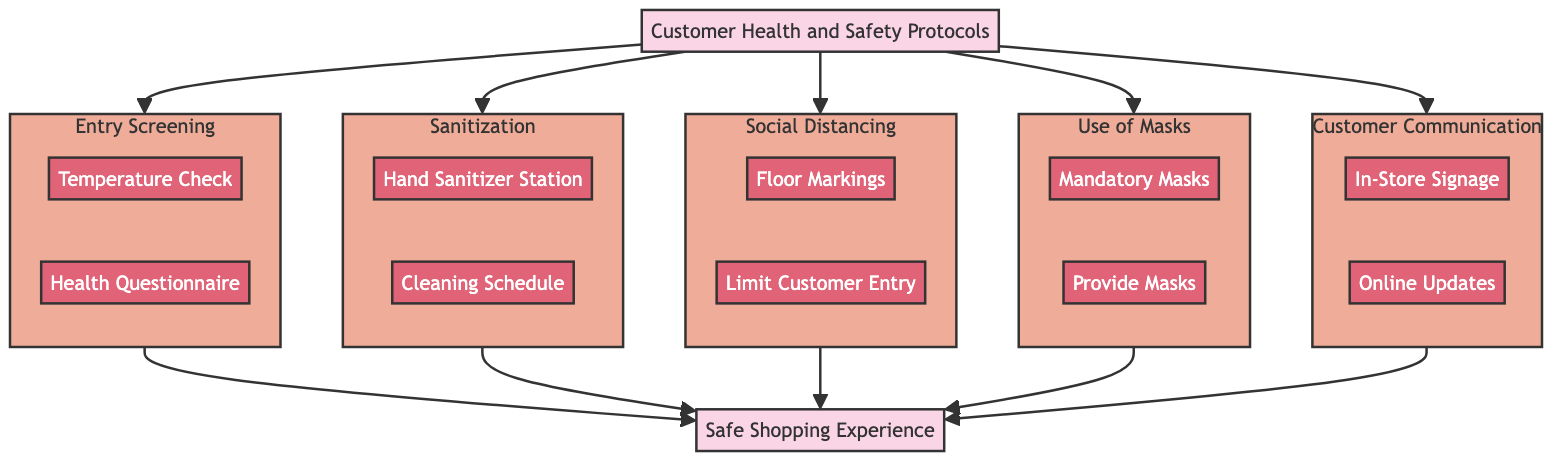What is the title of the clinical pathway? The title can be found at the beginning of the diagram. It states "Customer Health and Safety Protocols in Vinyl Record Store."
Answer: Customer Health and Safety Protocols in Vinyl Record Store How many steps are in the diagram? The diagram visually represents five steps that are connected to the main title node. This can be counted easily.
Answer: 5 Which responsible party is tasked with the 'Temperature Check'? By looking into the activities of the first step, it clearly states that 'Store Staff' are responsible for this activity.
Answer: Store Staff What is the purpose of floor markings? Upon reviewing the relevant activity in the third step, it indicates that the markings help define safe distances in checkout lines and browsing sections.
Answer: Indicate safe distances Which step involves the 'Health Questionnaire'? The 'Health Questionnaire' is an activity listed under the first step, 'Entry Screening.' This is readily noted in the organization of the diagram.
Answer: Entry Screening What are customers required to wear inside the store? The fourth step clearly states that 'all customers and staff' must wear masks inside the store as a part of the health protocols.
Answer: Masks What is the final outcome of adhering to these protocols? The conclusion of the diagram summarizes that these protocols ensure a 'Safe Shopping Experience,' which is the last node connected to all steps.
Answer: Safe Shopping Experience What does the 'Cleaning Schedule' activity refer to? By examining the second step, it states that 'Cleaning Schedule' refers to disinfecting high-touch surfaces in the store, clarifying the specific action in this context.
Answer: Disinfecting high-touch surfaces What does the 'Online Updates' activity entail? In the fifth step, the 'Online Updates' activity involves updating the store's website and social media with current safety protocols, clarifying its purpose.
Answer: Updating website and social media What is the responsible party for the 'Hand Sanitizer Station'? The second step identifies that 'Store Management' is responsible for providing the 'Hand Sanitizer Station' at various points within the store.
Answer: Store Management 